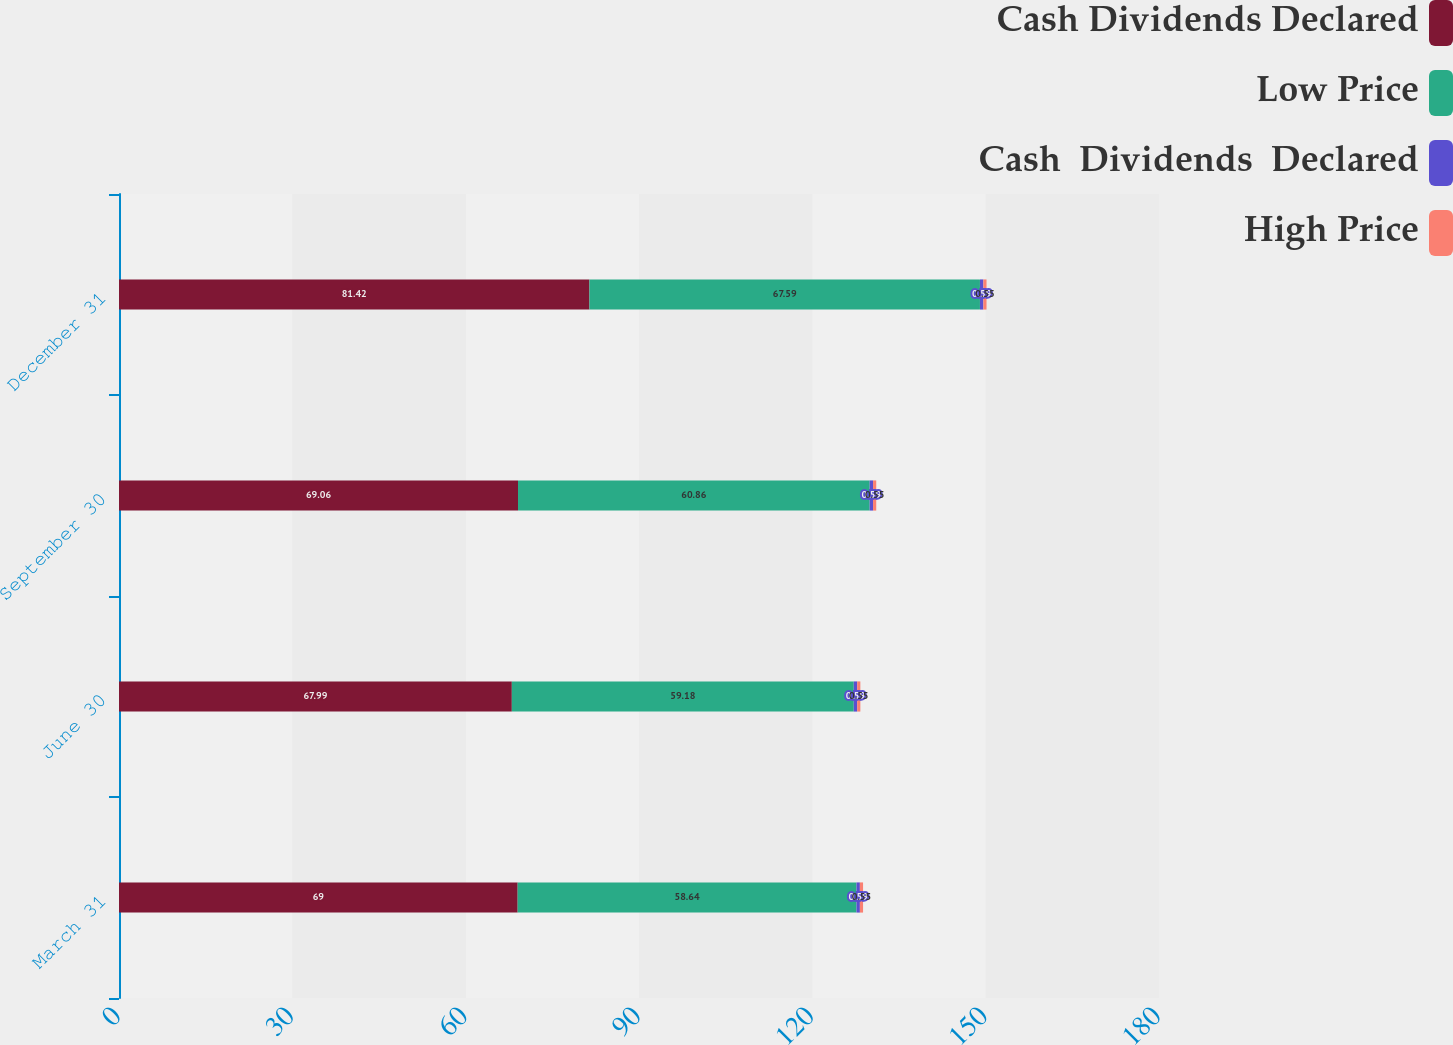Convert chart. <chart><loc_0><loc_0><loc_500><loc_500><stacked_bar_chart><ecel><fcel>March 31<fcel>June 30<fcel>September 30<fcel>December 31<nl><fcel>Cash Dividends Declared<fcel>69<fcel>67.99<fcel>69.06<fcel>81.42<nl><fcel>Low Price<fcel>58.64<fcel>59.18<fcel>60.86<fcel>67.59<nl><fcel>Cash  Dividends  Declared<fcel>0.59<fcel>0.59<fcel>0.59<fcel>0.59<nl><fcel>High Price<fcel>0.55<fcel>0.55<fcel>0.55<fcel>0.55<nl></chart> 